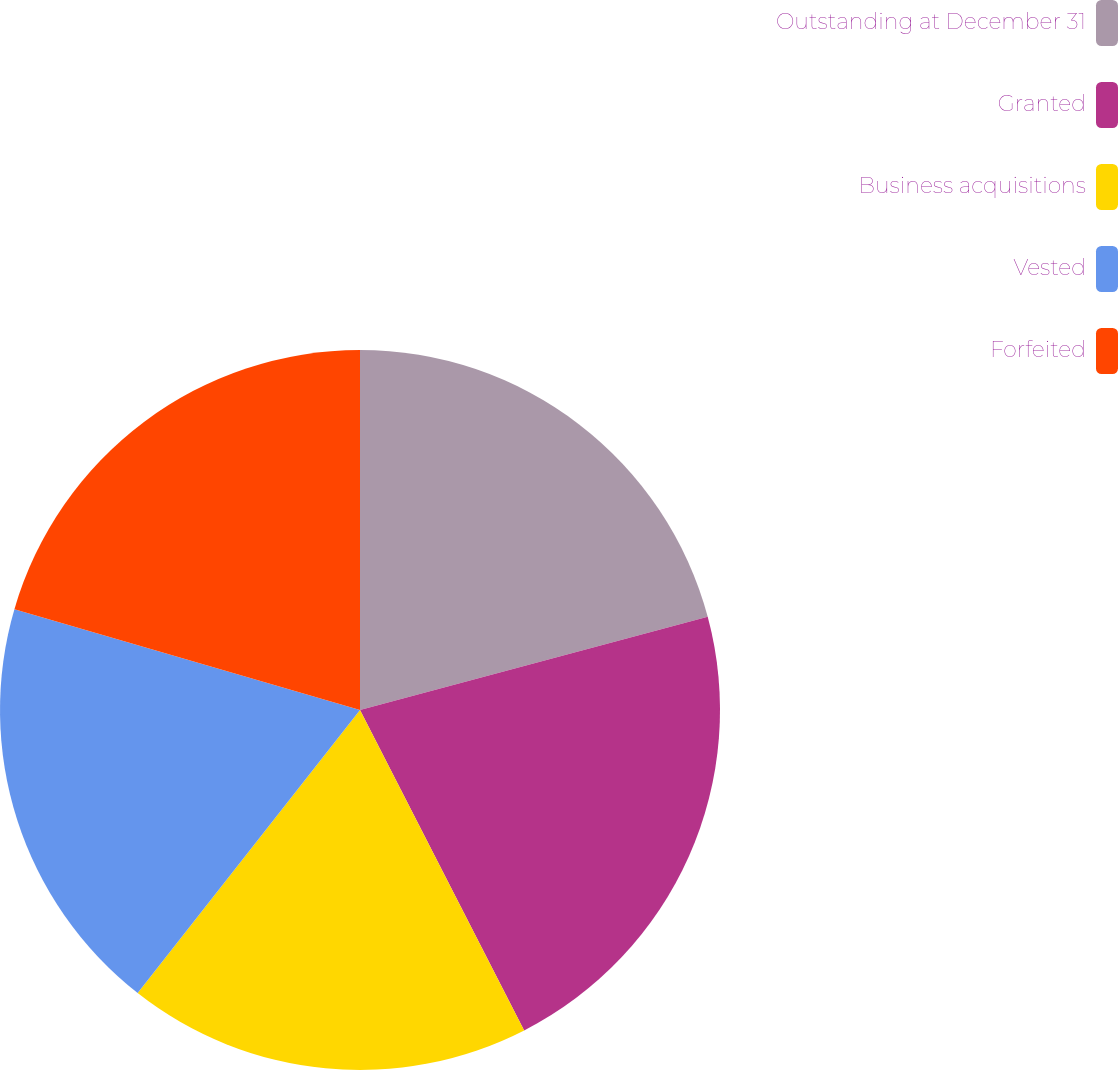<chart> <loc_0><loc_0><loc_500><loc_500><pie_chart><fcel>Outstanding at December 31<fcel>Granted<fcel>Business acquisitions<fcel>Vested<fcel>Forfeited<nl><fcel>20.83%<fcel>21.63%<fcel>18.13%<fcel>18.92%<fcel>20.48%<nl></chart> 